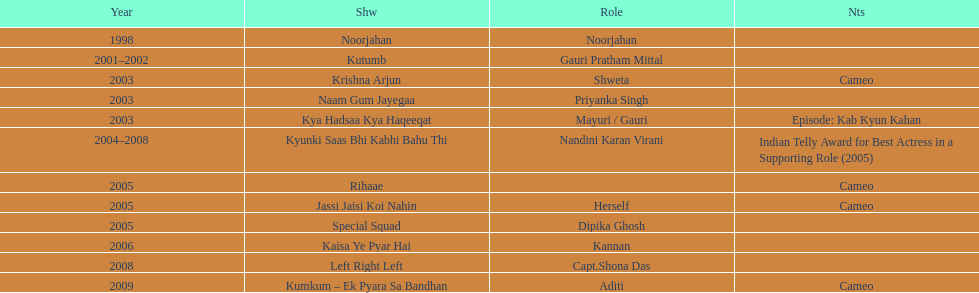What are all of the shows? Noorjahan, Kutumb, Krishna Arjun, Naam Gum Jayegaa, Kya Hadsaa Kya Haqeeqat, Kyunki Saas Bhi Kabhi Bahu Thi, Rihaae, Jassi Jaisi Koi Nahin, Special Squad, Kaisa Ye Pyar Hai, Left Right Left, Kumkum – Ek Pyara Sa Bandhan. When did they premiere? 1998, 2001–2002, 2003, 2003, 2003, 2004–2008, 2005, 2005, 2005, 2006, 2008, 2009. What notes are there for the shows from 2005? Cameo, Cameo. Along with rihaee, what is the other show gauri had a cameo role in? Jassi Jaisi Koi Nahin. 